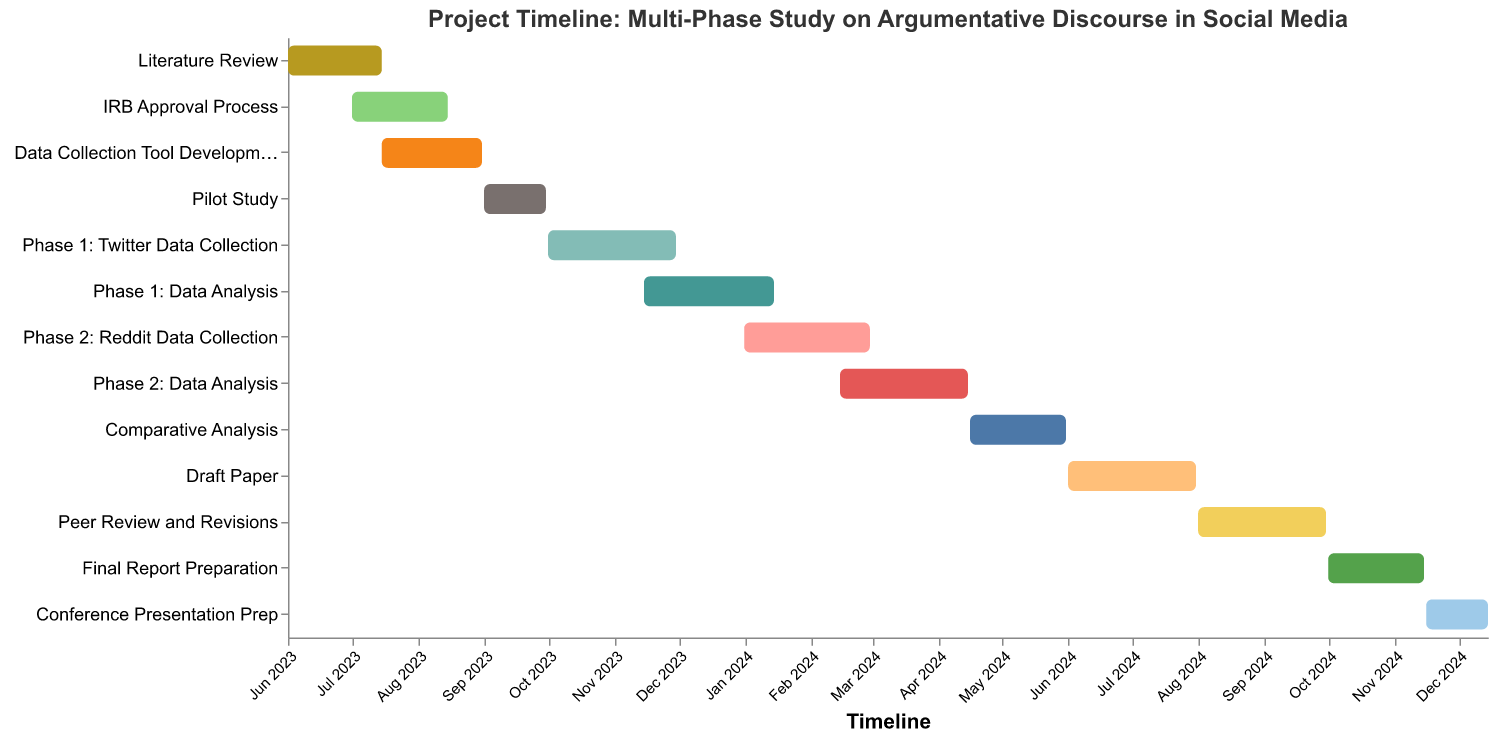What's the title of the figure? The title of a figure is typically located at the top and provides a brief description of what the figure represents. By looking at the top of this chart, we can see the title.
Answer: Project Timeline: Multi-Phase Study on Argumentative Discourse in Social Media Which task begins in June 2023? To determine this, we focus on the "Start" dates in June 2023 and check the corresponding task.
Answer: Literature Review How long does the Pilot Study last? The Pilot Study starts on 2023-09-01 and ends on 2023-09-30. By calculating the days between, we find the duration.
Answer: 30 days Which tasks overlap in July 2023? We need to look for tasks with start and end dates that include July 2023. These tasks would overlap during this month.
Answer: Literature Review, IRB Approval Process, Data Collection Tool Development When does the Data Collection Tool Development start and end? Check the "Start" and "End" dates for the Data Collection Tool Development task to find the respective dates.
Answer: Starts on 2023-07-15, ends on 2023-08-31 Which phase has data collection processes first, Twitter or Reddit? Identify the start dates for the data collection phases for both Twitter and Reddit. Compare the dates to see which comes first.
Answer: Twitter Data Collection How many tasks are planned to be completed by the end of December 2023? Review the end dates for all tasks and count those that are before or on December 31, 2023.
Answer: 5 tasks What tasks run concurrently with Peer Review and Revisions? Identify the start and end dates of Peer Review and Revisions, then find other tasks with overlapping dates.
Answer: Draft Paper Which task finishes last in the entire project timeline? Look for the task with the latest end date in the chart to determine which one finishes last.
Answer: Conference Presentation Prep Between the Literature Review and IRB Approval Process, which takes a shorter time to complete? Calculate the duration of both tasks by subtracting the start date from the end date. Compare the durations to find which one is shorter.
Answer: Literature Review 